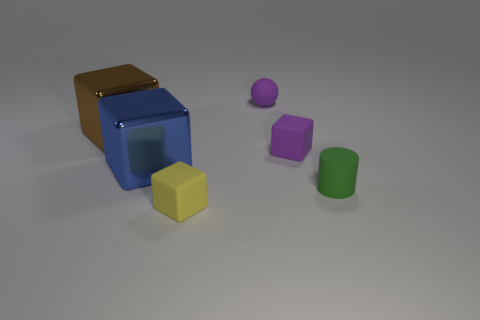Subtract 1 blocks. How many blocks are left? 3 Add 3 rubber cylinders. How many objects exist? 9 Subtract all blocks. How many objects are left? 2 Add 5 tiny purple matte things. How many tiny purple matte things are left? 7 Add 5 rubber things. How many rubber things exist? 9 Subtract 0 brown cylinders. How many objects are left? 6 Subtract all tiny purple blocks. Subtract all green matte things. How many objects are left? 4 